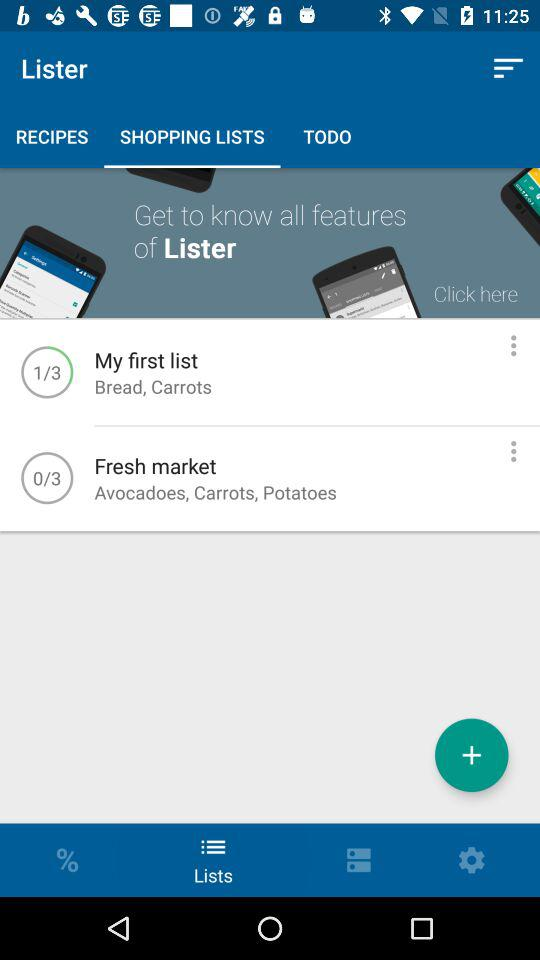Which tab is selected? The selected tab is "SHOPPING LISTS". 